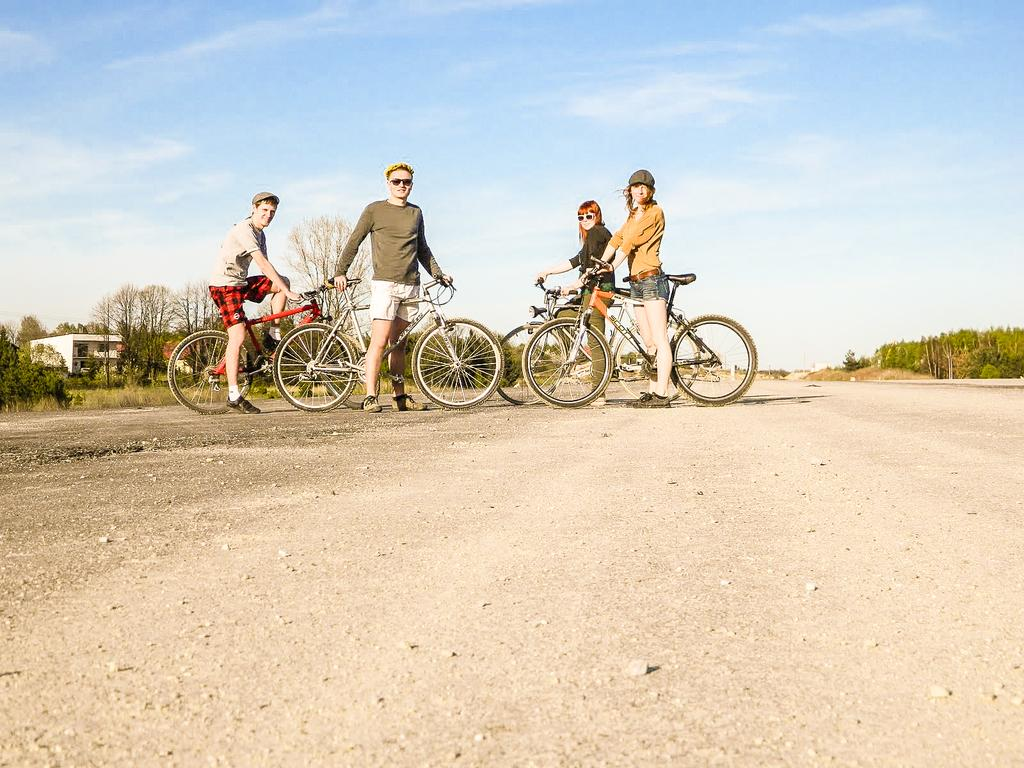How many people are in the image? There are four people in the image, two men and two women. What are the individuals holding in the image? The individuals are holding bicycles. Who is sitting on the bicycles? Two people are sitting on the bicycles. What can be seen in the background of the image? There are trees, buildings, a road, and the sky visible in the background of the image. What is the condition of the sky in the image? The sky is visible in the background of the image, and clouds are present. Who is attacking the person with a ball in the image? There is no person being attacked with a ball in the image. The image features four people holding bicycles, with two of them sitting on the bicycles, and a background that includes trees, buildings, a road, and the sky with clouds. 